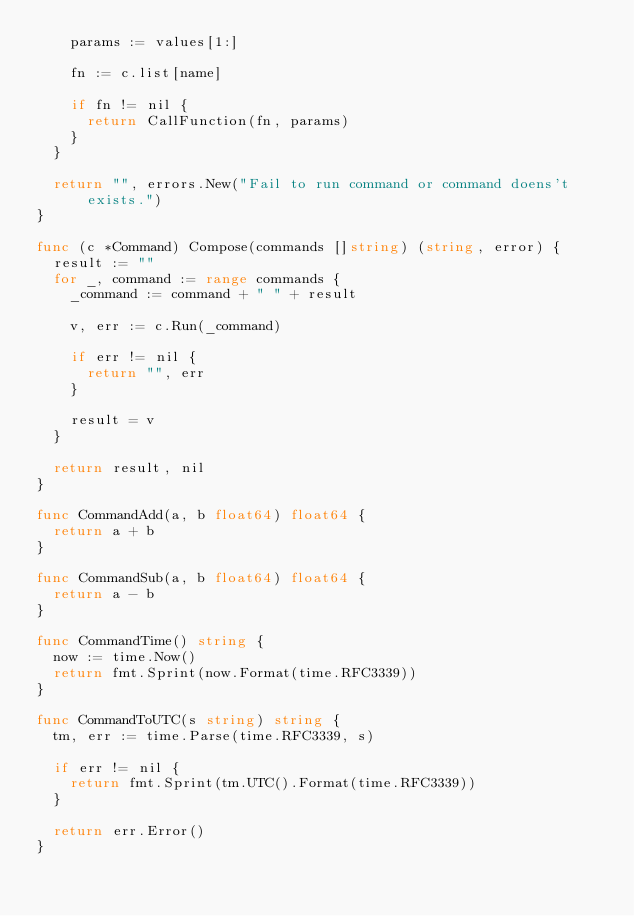<code> <loc_0><loc_0><loc_500><loc_500><_Go_>    params := values[1:]

    fn := c.list[name]

    if fn != nil {
      return CallFunction(fn, params)
    }
  }

  return "", errors.New("Fail to run command or command doens't exists.")
}

func (c *Command) Compose(commands []string) (string, error) {
  result := ""
  for _, command := range commands {
    _command := command + " " + result 

    v, err := c.Run(_command)

    if err != nil {
      return "", err
    }

    result = v
  }

  return result, nil
}

func CommandAdd(a, b float64) float64 {
  return a + b
}

func CommandSub(a, b float64) float64 {
  return a - b
}

func CommandTime() string {
  now := time.Now()
  return fmt.Sprint(now.Format(time.RFC3339))
}

func CommandToUTC(s string) string {
  tm, err := time.Parse(time.RFC3339, s)

  if err != nil {
    return fmt.Sprint(tm.UTC().Format(time.RFC3339))
  }

  return err.Error()
}
</code> 